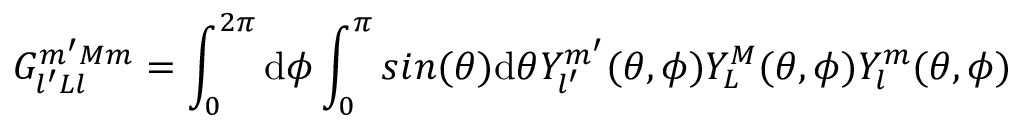Convert formula to latex. <formula><loc_0><loc_0><loc_500><loc_500>G _ { l ^ { \prime } L l } ^ { m ^ { \prime } M m } = \int _ { 0 } ^ { 2 \pi } d { \phi } \int _ { 0 } ^ { \pi } \sin ( \theta ) d { \theta } { Y _ { l ^ { \prime } } ^ { m ^ { \prime } } } ( \theta , \phi ) Y _ { L } ^ { M } ( \theta , \phi ) Y _ { l } ^ { m } ( \theta , \phi )</formula> 